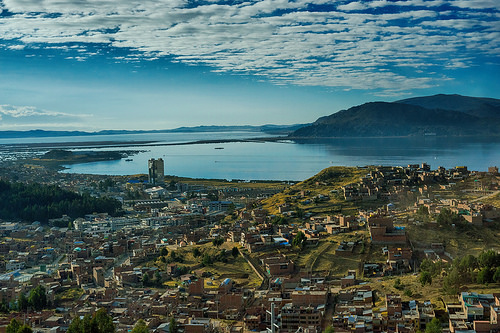<image>
Is the sky behind the mountain? Yes. From this viewpoint, the sky is positioned behind the mountain, with the mountain partially or fully occluding the sky. 